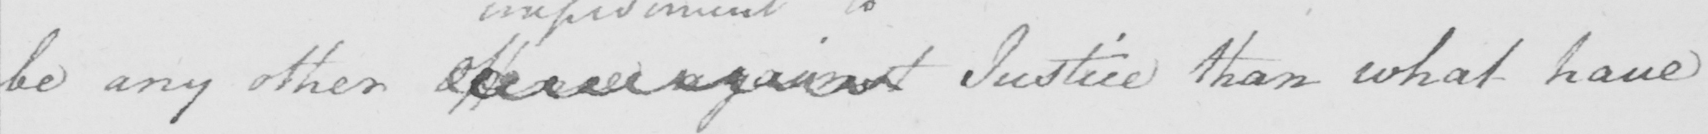What text is written in this handwritten line? be any other offered against Justice than what have 